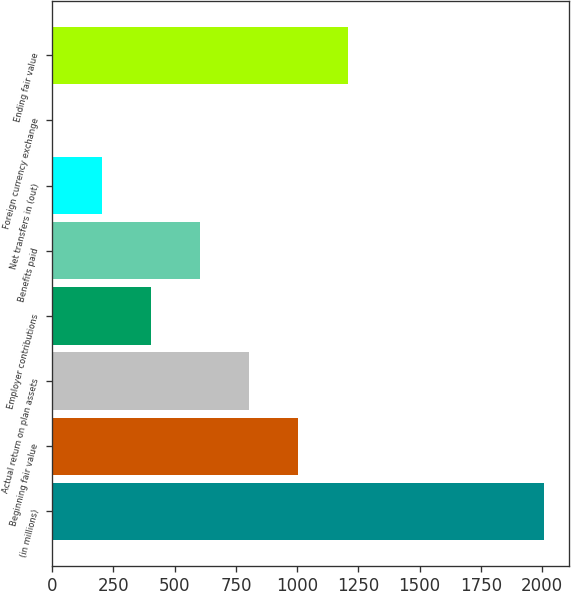<chart> <loc_0><loc_0><loc_500><loc_500><bar_chart><fcel>(in millions)<fcel>Beginning fair value<fcel>Actual return on plan assets<fcel>Employer contributions<fcel>Benefits paid<fcel>Net transfers in (out)<fcel>Foreign currency exchange<fcel>Ending fair value<nl><fcel>2009<fcel>1005<fcel>804.2<fcel>402.6<fcel>603.4<fcel>201.8<fcel>1<fcel>1205.8<nl></chart> 